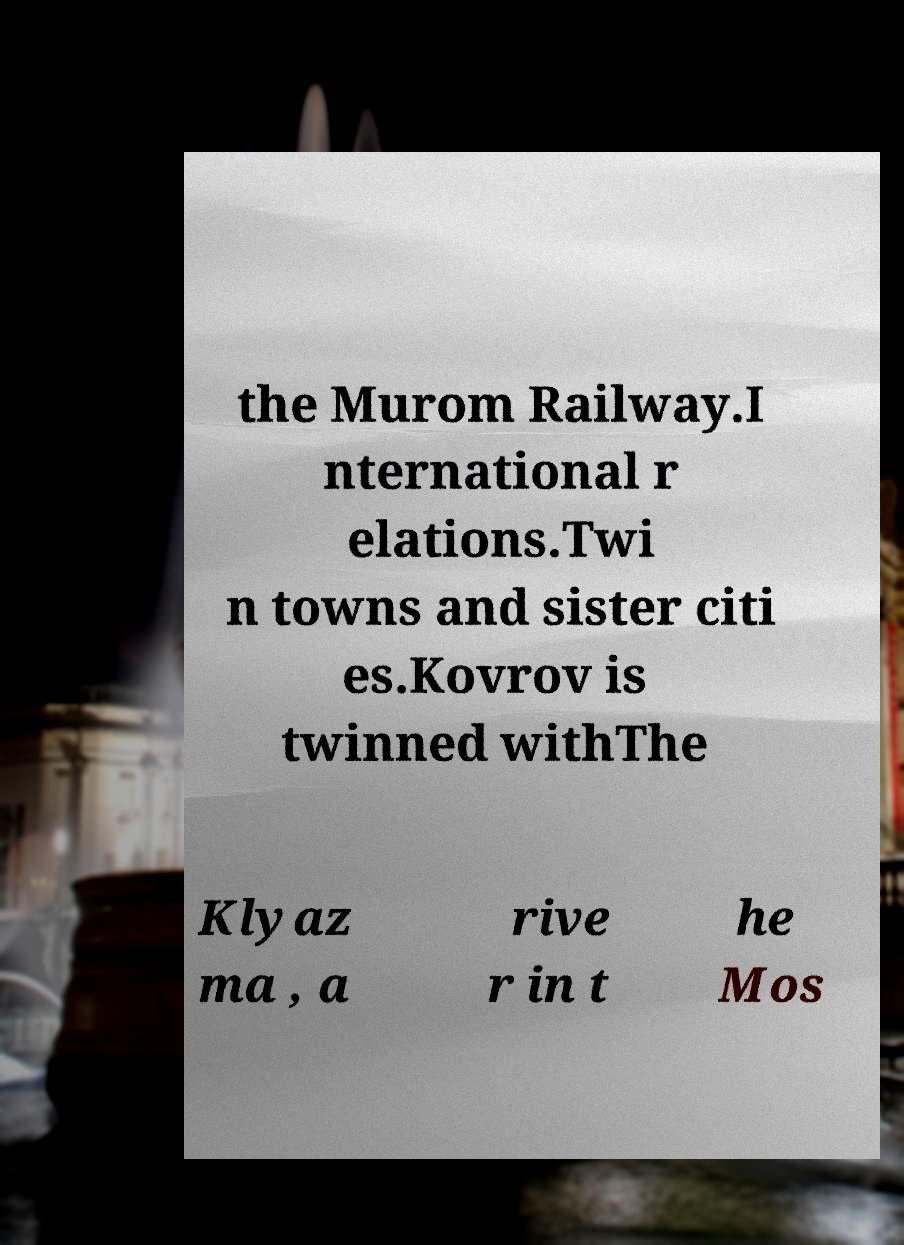There's text embedded in this image that I need extracted. Can you transcribe it verbatim? the Murom Railway.I nternational r elations.Twi n towns and sister citi es.Kovrov is twinned withThe Klyaz ma , a rive r in t he Mos 